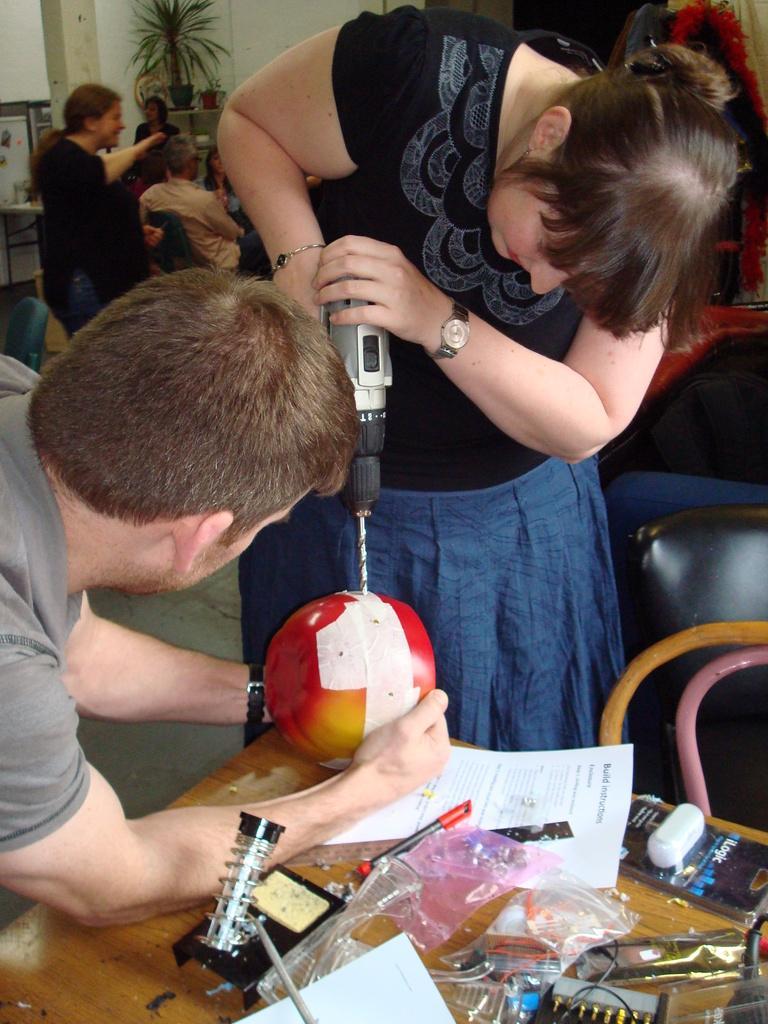Could you give a brief overview of what you see in this image? The woman in the black dress is holding a drilling machine and she is drilling a hole to the red color object which looks like a ball. Beside her, we see the man is holding the red color object. In front of them, we see a table on which plastic cover, paper, pen and some objects are placed. Beside that, we see a chair. Behind them, we see people are standing and a man is sitting on the chair. In the background, we see flower pots and a white wall on which photo frame is placed. 